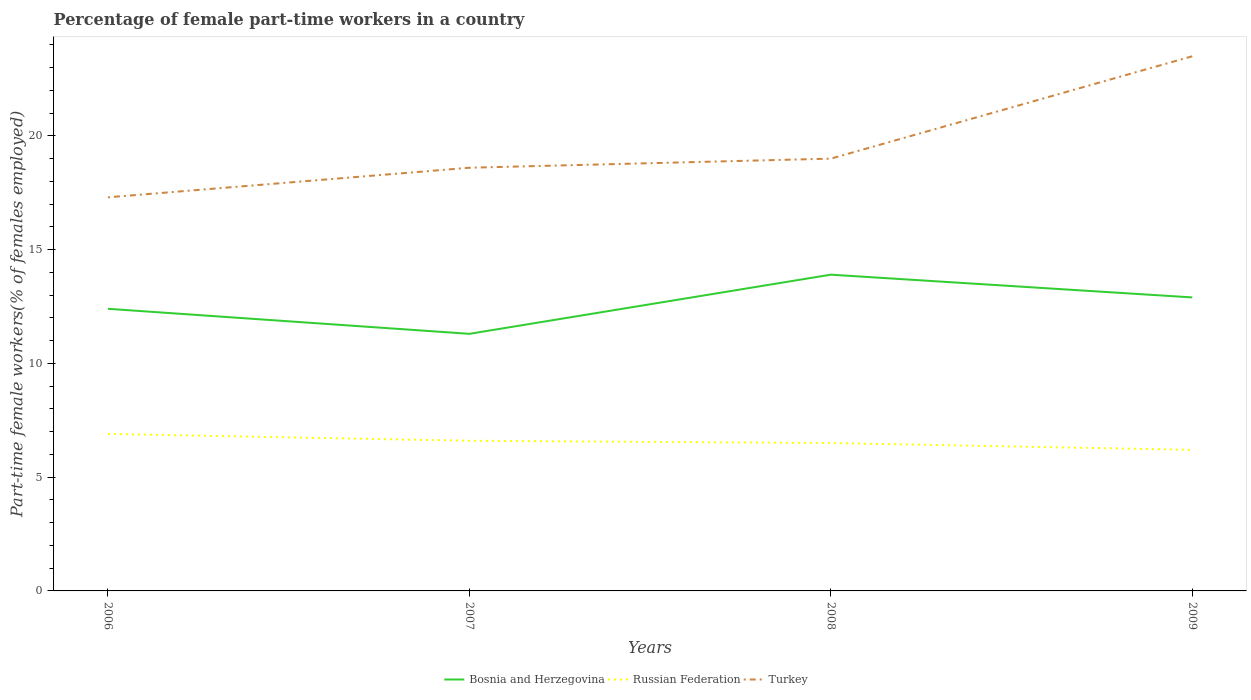Does the line corresponding to Russian Federation intersect with the line corresponding to Turkey?
Your answer should be compact. No. Across all years, what is the maximum percentage of female part-time workers in Turkey?
Your answer should be very brief. 17.3. What is the total percentage of female part-time workers in Turkey in the graph?
Offer a very short reply. -0.4. What is the difference between the highest and the second highest percentage of female part-time workers in Bosnia and Herzegovina?
Provide a short and direct response. 2.6. Is the percentage of female part-time workers in Turkey strictly greater than the percentage of female part-time workers in Russian Federation over the years?
Keep it short and to the point. No. How many lines are there?
Ensure brevity in your answer.  3. Are the values on the major ticks of Y-axis written in scientific E-notation?
Offer a terse response. No. How are the legend labels stacked?
Offer a very short reply. Horizontal. What is the title of the graph?
Provide a short and direct response. Percentage of female part-time workers in a country. Does "Turks and Caicos Islands" appear as one of the legend labels in the graph?
Provide a short and direct response. No. What is the label or title of the X-axis?
Offer a very short reply. Years. What is the label or title of the Y-axis?
Your answer should be compact. Part-time female workers(% of females employed). What is the Part-time female workers(% of females employed) in Bosnia and Herzegovina in 2006?
Your answer should be very brief. 12.4. What is the Part-time female workers(% of females employed) in Russian Federation in 2006?
Make the answer very short. 6.9. What is the Part-time female workers(% of females employed) in Turkey in 2006?
Ensure brevity in your answer.  17.3. What is the Part-time female workers(% of females employed) of Bosnia and Herzegovina in 2007?
Provide a succinct answer. 11.3. What is the Part-time female workers(% of females employed) in Russian Federation in 2007?
Ensure brevity in your answer.  6.6. What is the Part-time female workers(% of females employed) in Turkey in 2007?
Your response must be concise. 18.6. What is the Part-time female workers(% of females employed) in Bosnia and Herzegovina in 2008?
Keep it short and to the point. 13.9. What is the Part-time female workers(% of females employed) of Russian Federation in 2008?
Offer a terse response. 6.5. What is the Part-time female workers(% of females employed) of Bosnia and Herzegovina in 2009?
Your answer should be very brief. 12.9. What is the Part-time female workers(% of females employed) in Russian Federation in 2009?
Ensure brevity in your answer.  6.2. Across all years, what is the maximum Part-time female workers(% of females employed) in Bosnia and Herzegovina?
Keep it short and to the point. 13.9. Across all years, what is the maximum Part-time female workers(% of females employed) of Russian Federation?
Your answer should be very brief. 6.9. Across all years, what is the minimum Part-time female workers(% of females employed) of Bosnia and Herzegovina?
Provide a succinct answer. 11.3. Across all years, what is the minimum Part-time female workers(% of females employed) of Russian Federation?
Provide a succinct answer. 6.2. Across all years, what is the minimum Part-time female workers(% of females employed) in Turkey?
Provide a succinct answer. 17.3. What is the total Part-time female workers(% of females employed) of Bosnia and Herzegovina in the graph?
Your response must be concise. 50.5. What is the total Part-time female workers(% of females employed) of Russian Federation in the graph?
Give a very brief answer. 26.2. What is the total Part-time female workers(% of females employed) in Turkey in the graph?
Your response must be concise. 78.4. What is the difference between the Part-time female workers(% of females employed) in Bosnia and Herzegovina in 2006 and that in 2007?
Keep it short and to the point. 1.1. What is the difference between the Part-time female workers(% of females employed) of Turkey in 2006 and that in 2007?
Ensure brevity in your answer.  -1.3. What is the difference between the Part-time female workers(% of females employed) in Russian Federation in 2006 and that in 2008?
Provide a succinct answer. 0.4. What is the difference between the Part-time female workers(% of females employed) in Turkey in 2006 and that in 2008?
Offer a terse response. -1.7. What is the difference between the Part-time female workers(% of females employed) of Turkey in 2006 and that in 2009?
Your answer should be compact. -6.2. What is the difference between the Part-time female workers(% of females employed) of Turkey in 2007 and that in 2008?
Your answer should be compact. -0.4. What is the difference between the Part-time female workers(% of females employed) in Russian Federation in 2007 and that in 2009?
Provide a succinct answer. 0.4. What is the difference between the Part-time female workers(% of females employed) of Bosnia and Herzegovina in 2008 and that in 2009?
Give a very brief answer. 1. What is the difference between the Part-time female workers(% of females employed) of Russian Federation in 2008 and that in 2009?
Offer a terse response. 0.3. What is the difference between the Part-time female workers(% of females employed) of Bosnia and Herzegovina in 2006 and the Part-time female workers(% of females employed) of Russian Federation in 2007?
Make the answer very short. 5.8. What is the difference between the Part-time female workers(% of females employed) in Bosnia and Herzegovina in 2006 and the Part-time female workers(% of females employed) in Turkey in 2007?
Offer a terse response. -6.2. What is the difference between the Part-time female workers(% of females employed) of Russian Federation in 2006 and the Part-time female workers(% of females employed) of Turkey in 2007?
Offer a terse response. -11.7. What is the difference between the Part-time female workers(% of females employed) of Bosnia and Herzegovina in 2006 and the Part-time female workers(% of females employed) of Turkey in 2008?
Keep it short and to the point. -6.6. What is the difference between the Part-time female workers(% of females employed) of Bosnia and Herzegovina in 2006 and the Part-time female workers(% of females employed) of Russian Federation in 2009?
Your response must be concise. 6.2. What is the difference between the Part-time female workers(% of females employed) of Russian Federation in 2006 and the Part-time female workers(% of females employed) of Turkey in 2009?
Give a very brief answer. -16.6. What is the difference between the Part-time female workers(% of females employed) in Bosnia and Herzegovina in 2007 and the Part-time female workers(% of females employed) in Turkey in 2008?
Your answer should be very brief. -7.7. What is the difference between the Part-time female workers(% of females employed) in Russian Federation in 2007 and the Part-time female workers(% of females employed) in Turkey in 2009?
Ensure brevity in your answer.  -16.9. What is the difference between the Part-time female workers(% of females employed) in Bosnia and Herzegovina in 2008 and the Part-time female workers(% of females employed) in Russian Federation in 2009?
Your answer should be very brief. 7.7. What is the average Part-time female workers(% of females employed) in Bosnia and Herzegovina per year?
Your response must be concise. 12.62. What is the average Part-time female workers(% of females employed) in Russian Federation per year?
Keep it short and to the point. 6.55. What is the average Part-time female workers(% of females employed) in Turkey per year?
Ensure brevity in your answer.  19.6. In the year 2006, what is the difference between the Part-time female workers(% of females employed) of Bosnia and Herzegovina and Part-time female workers(% of females employed) of Turkey?
Your response must be concise. -4.9. In the year 2008, what is the difference between the Part-time female workers(% of females employed) in Bosnia and Herzegovina and Part-time female workers(% of females employed) in Russian Federation?
Give a very brief answer. 7.4. In the year 2009, what is the difference between the Part-time female workers(% of females employed) of Russian Federation and Part-time female workers(% of females employed) of Turkey?
Provide a succinct answer. -17.3. What is the ratio of the Part-time female workers(% of females employed) of Bosnia and Herzegovina in 2006 to that in 2007?
Your response must be concise. 1.1. What is the ratio of the Part-time female workers(% of females employed) in Russian Federation in 2006 to that in 2007?
Your answer should be very brief. 1.05. What is the ratio of the Part-time female workers(% of females employed) in Turkey in 2006 to that in 2007?
Provide a short and direct response. 0.93. What is the ratio of the Part-time female workers(% of females employed) in Bosnia and Herzegovina in 2006 to that in 2008?
Offer a very short reply. 0.89. What is the ratio of the Part-time female workers(% of females employed) in Russian Federation in 2006 to that in 2008?
Offer a terse response. 1.06. What is the ratio of the Part-time female workers(% of females employed) of Turkey in 2006 to that in 2008?
Provide a short and direct response. 0.91. What is the ratio of the Part-time female workers(% of females employed) of Bosnia and Herzegovina in 2006 to that in 2009?
Keep it short and to the point. 0.96. What is the ratio of the Part-time female workers(% of females employed) in Russian Federation in 2006 to that in 2009?
Offer a terse response. 1.11. What is the ratio of the Part-time female workers(% of females employed) of Turkey in 2006 to that in 2009?
Your response must be concise. 0.74. What is the ratio of the Part-time female workers(% of females employed) in Bosnia and Herzegovina in 2007 to that in 2008?
Provide a short and direct response. 0.81. What is the ratio of the Part-time female workers(% of females employed) of Russian Federation in 2007 to that in 2008?
Keep it short and to the point. 1.02. What is the ratio of the Part-time female workers(% of females employed) of Turkey in 2007 to that in 2008?
Provide a succinct answer. 0.98. What is the ratio of the Part-time female workers(% of females employed) in Bosnia and Herzegovina in 2007 to that in 2009?
Offer a terse response. 0.88. What is the ratio of the Part-time female workers(% of females employed) of Russian Federation in 2007 to that in 2009?
Your response must be concise. 1.06. What is the ratio of the Part-time female workers(% of females employed) in Turkey in 2007 to that in 2009?
Keep it short and to the point. 0.79. What is the ratio of the Part-time female workers(% of females employed) in Bosnia and Herzegovina in 2008 to that in 2009?
Provide a short and direct response. 1.08. What is the ratio of the Part-time female workers(% of females employed) in Russian Federation in 2008 to that in 2009?
Offer a very short reply. 1.05. What is the ratio of the Part-time female workers(% of females employed) in Turkey in 2008 to that in 2009?
Provide a short and direct response. 0.81. What is the difference between the highest and the lowest Part-time female workers(% of females employed) in Bosnia and Herzegovina?
Your response must be concise. 2.6. What is the difference between the highest and the lowest Part-time female workers(% of females employed) in Russian Federation?
Give a very brief answer. 0.7. What is the difference between the highest and the lowest Part-time female workers(% of females employed) in Turkey?
Your answer should be very brief. 6.2. 